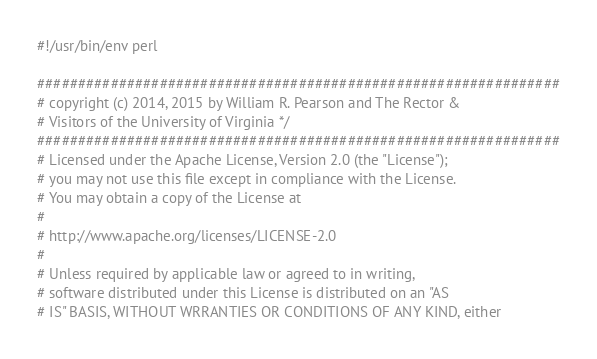Convert code to text. <code><loc_0><loc_0><loc_500><loc_500><_Perl_>#!/usr/bin/env perl

################################################################
# copyright (c) 2014, 2015 by William R. Pearson and The Rector &
# Visitors of the University of Virginia */
################################################################
# Licensed under the Apache License, Version 2.0 (the "License");
# you may not use this file except in compliance with the License.
# You may obtain a copy of the License at
#
# http://www.apache.org/licenses/LICENSE-2.0
#
# Unless required by applicable law or agreed to in writing,
# software distributed under this License is distributed on an "AS
# IS" BASIS, WITHOUT WRRANTIES OR CONDITIONS OF ANY KIND, either</code> 